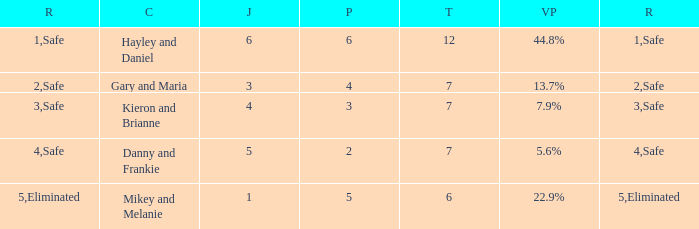How many public is there for the couple that got eliminated? 5.0. Would you be able to parse every entry in this table? {'header': ['R', 'C', 'J', 'P', 'T', 'VP', 'R'], 'rows': [['1', 'Hayley and Daniel', '6', '6', '12', '44.8%', 'Safe'], ['2', 'Gary and Maria', '3', '4', '7', '13.7%', 'Safe'], ['3', 'Kieron and Brianne', '4', '3', '7', '7.9%', 'Safe'], ['4', 'Danny and Frankie', '5', '2', '7', '5.6%', 'Safe'], ['5', 'Mikey and Melanie', '1', '5', '6', '22.9%', 'Eliminated']]} 